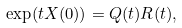<formula> <loc_0><loc_0><loc_500><loc_500>\exp ( t X ( 0 ) ) = Q ( t ) R ( t ) ,</formula> 